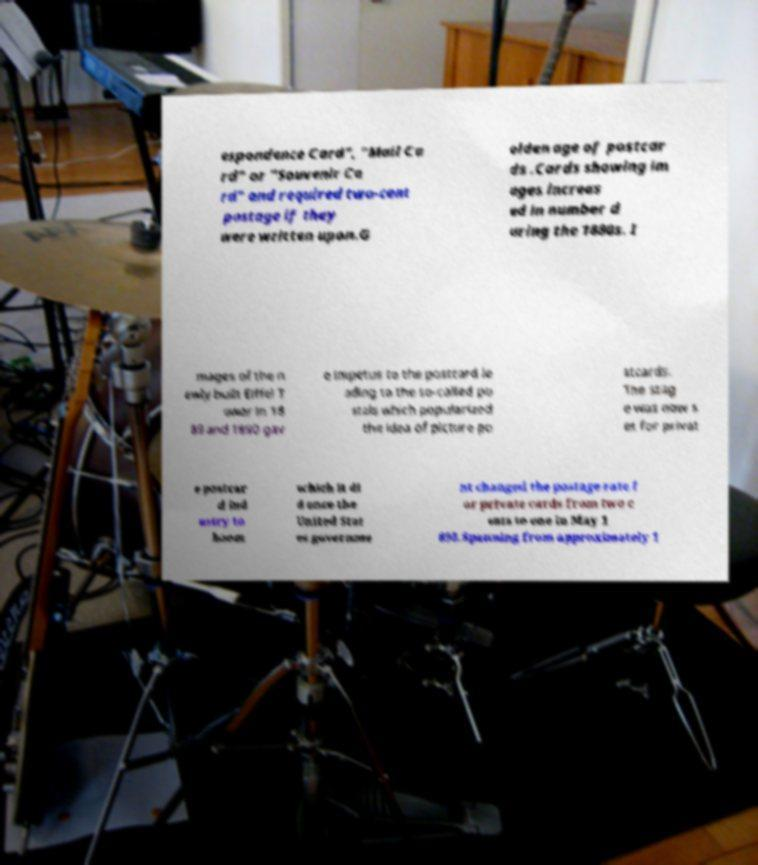Can you read and provide the text displayed in the image?This photo seems to have some interesting text. Can you extract and type it out for me? espondence Card", "Mail Ca rd" or "Souvenir Ca rd" and required two-cent postage if they were written upon.G olden age of postcar ds .Cards showing im ages increas ed in number d uring the 1880s. I mages of the n ewly built Eiffel T ower in 18 89 and 1890 gav e impetus to the postcard le ading to the so-called po stals which popularized the idea of picture po stcards. The stag e was now s et for privat e postcar d ind ustry to boom which it di d once the United Stat es governme nt changed the postage rate f or private cards from two c ents to one in May 1 898.Spanning from approximately 1 